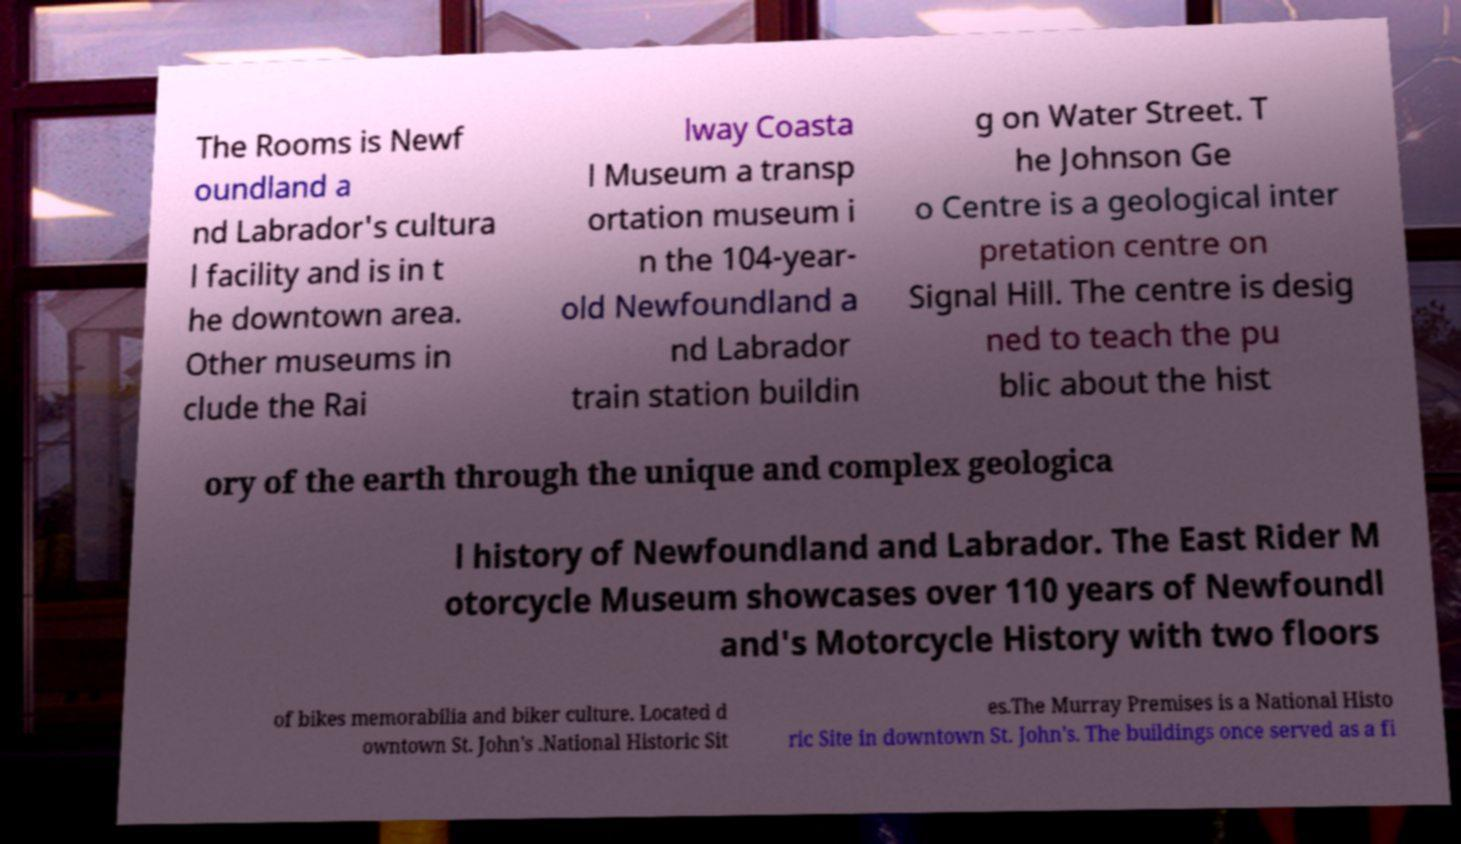Could you extract and type out the text from this image? The Rooms is Newf oundland a nd Labrador's cultura l facility and is in t he downtown area. Other museums in clude the Rai lway Coasta l Museum a transp ortation museum i n the 104-year- old Newfoundland a nd Labrador train station buildin g on Water Street. T he Johnson Ge o Centre is a geological inter pretation centre on Signal Hill. The centre is desig ned to teach the pu blic about the hist ory of the earth through the unique and complex geologica l history of Newfoundland and Labrador. The East Rider M otorcycle Museum showcases over 110 years of Newfoundl and's Motorcycle History with two floors of bikes memorabilia and biker culture. Located d owntown St. John's .National Historic Sit es.The Murray Premises is a National Histo ric Site in downtown St. John's. The buildings once served as a fi 